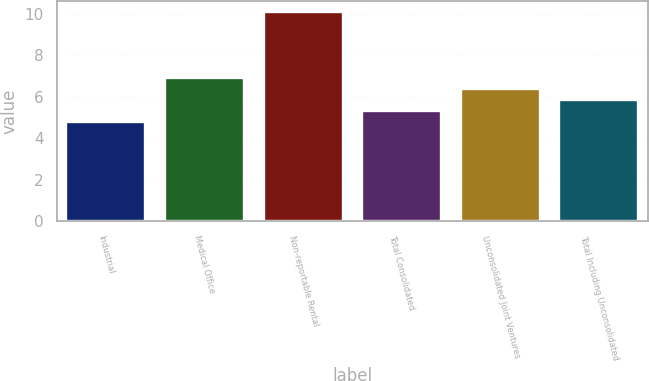Convert chart. <chart><loc_0><loc_0><loc_500><loc_500><bar_chart><fcel>Industrial<fcel>Medical Office<fcel>Non-reportable Rental<fcel>Total Consolidated<fcel>Unconsolidated Joint Ventures<fcel>Total Including Unconsolidated<nl><fcel>4.8<fcel>6.92<fcel>10.1<fcel>5.33<fcel>6.39<fcel>5.86<nl></chart> 